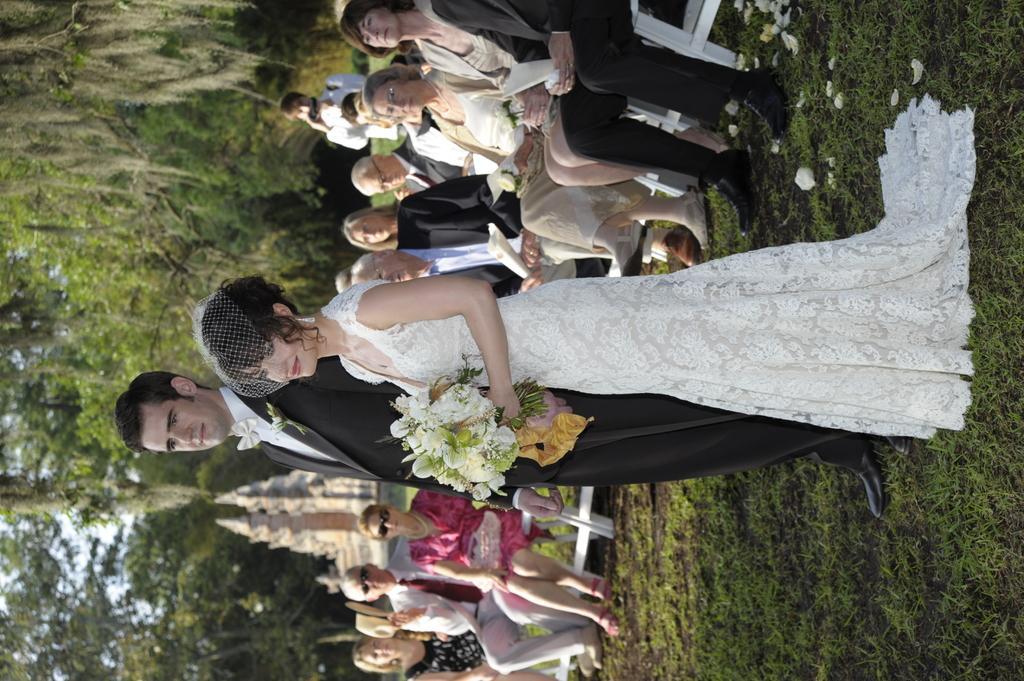Please provide a concise description of this image. In the middle, we see a man and a woman who is holding a flower bouquet are standing. Both of them are smiling and they are posing for the photo. On the right side, we see the grass. Behind them, we see the people sitting on the chairs or the benches. Behind them, we see a man in the white shirt is standing and he is clicking photos with the camera. There are trees and a building in the background. 